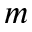Convert formula to latex. <formula><loc_0><loc_0><loc_500><loc_500>_ { m }</formula> 